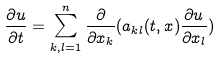<formula> <loc_0><loc_0><loc_500><loc_500>\frac { \partial u } { \partial t } = \sum _ { k , l = 1 } ^ { n } \frac { \partial } { \partial x _ { k } } ( a _ { k l } ( t , x ) \frac { \partial u } { \partial x _ { l } } )</formula> 